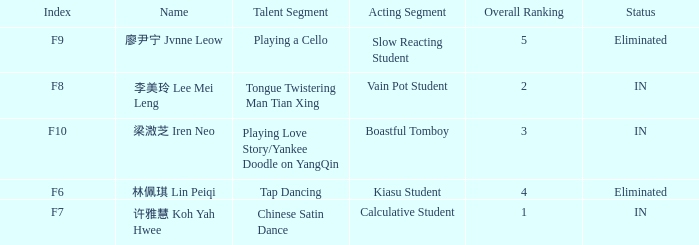What's the total number of overall rankings of 廖尹宁 jvnne leow's events that are eliminated? 1.0. 